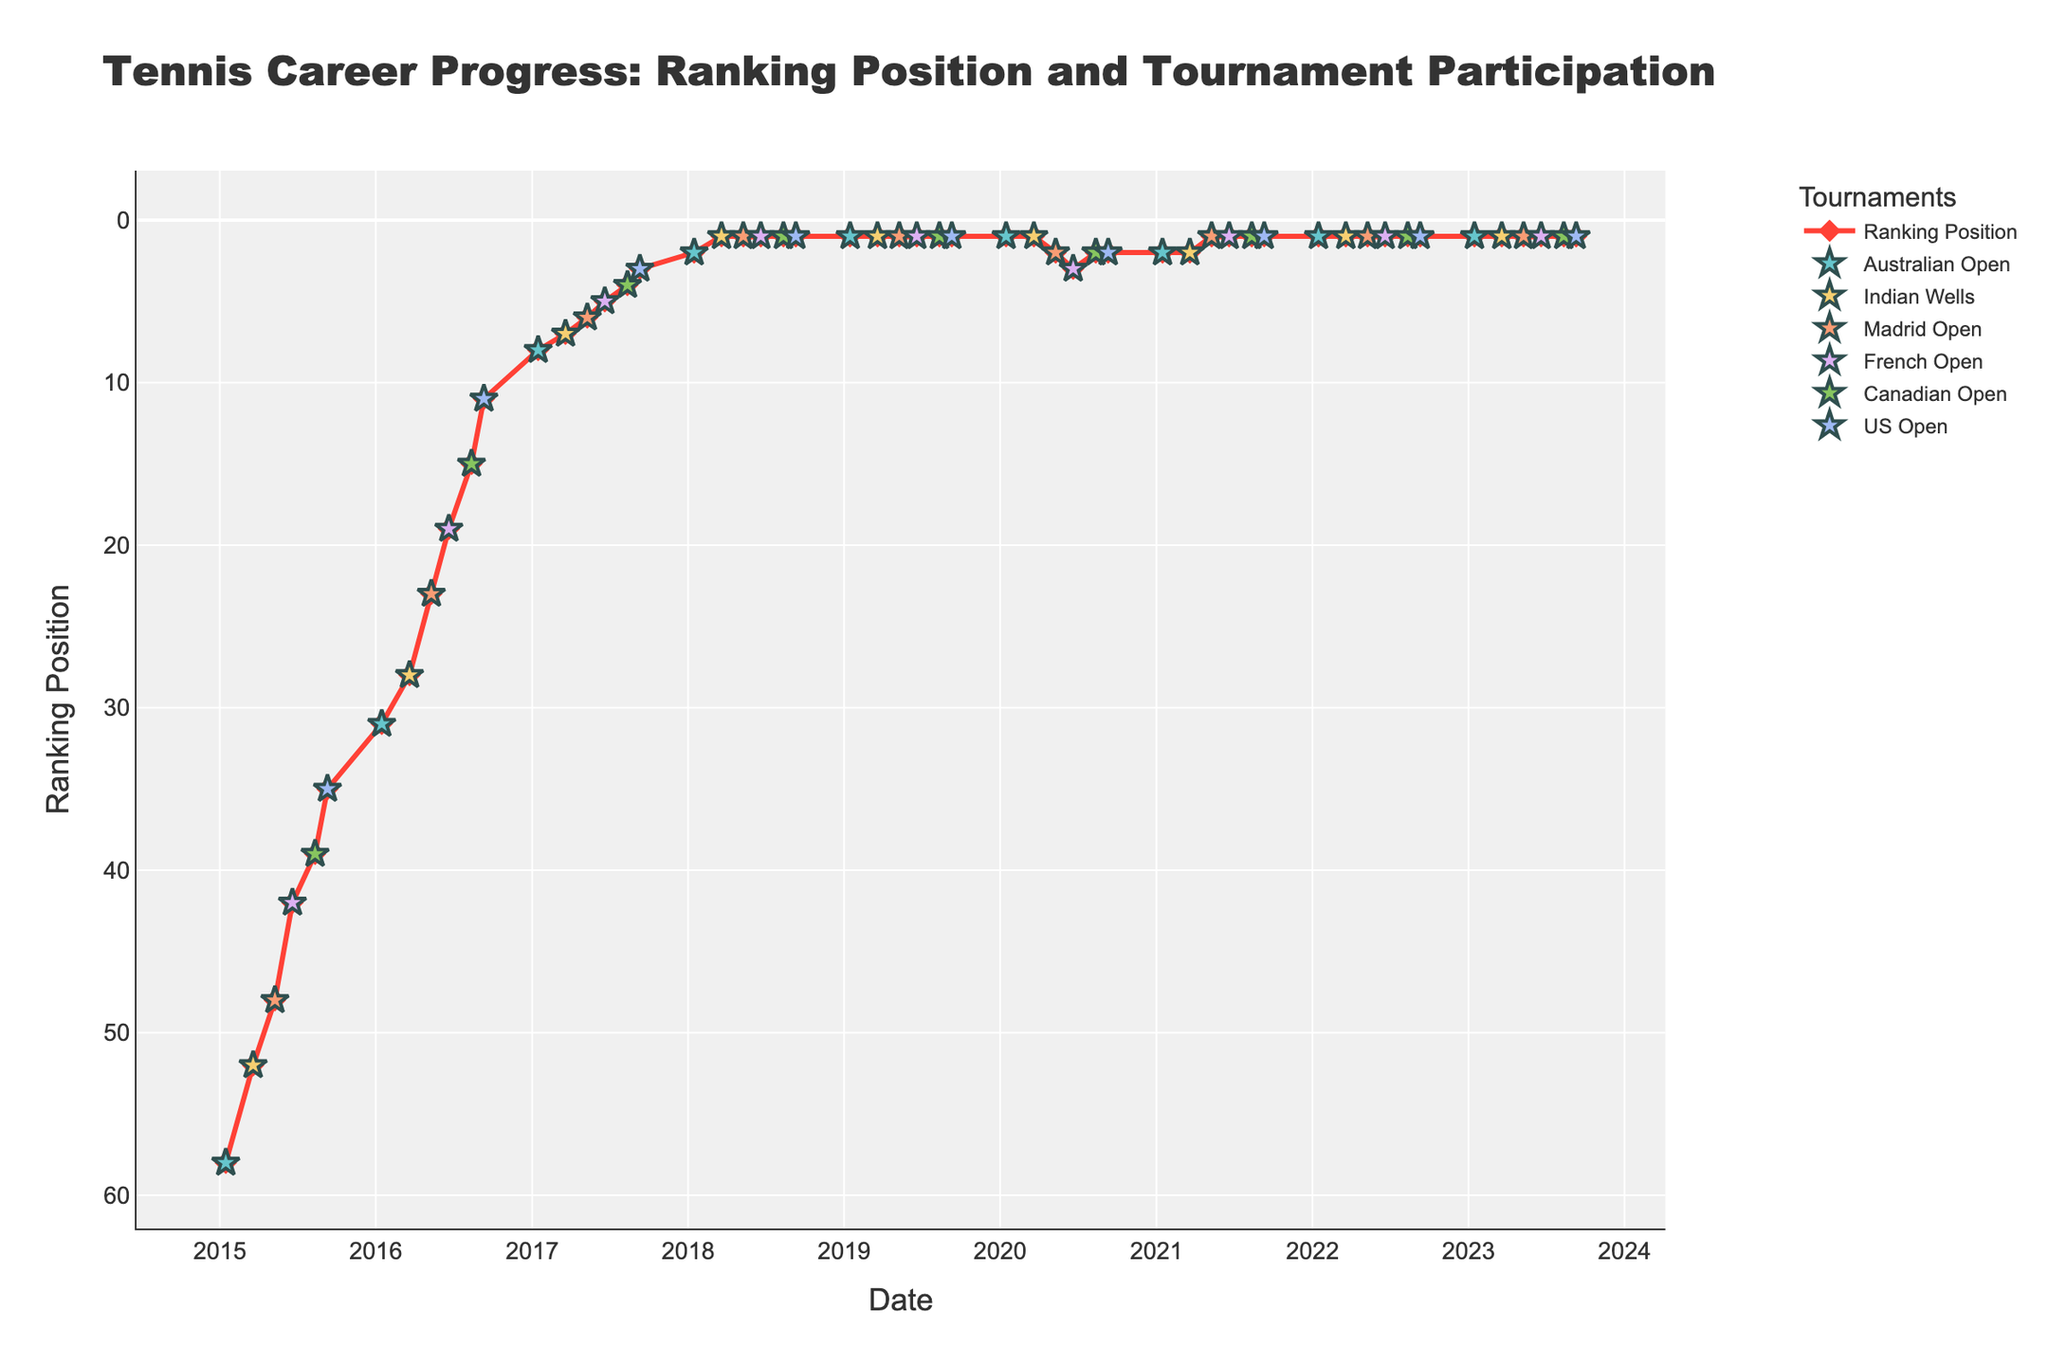What is the title of the plot? The title is displayed at the top of the plot. It's "Tennis Career Progress: Ranking Position and Tournament Participation".
Answer: Tennis Career Progress: Ranking Position and Tournament Participation What is the general trend of the ranking position from 2015 to 2018? To analyze the trend, look at the line that represents the ranking positions over time from 2015 to 2018. The ranking position consistently decreases, indicating improvement.
Answer: Improvement (ranking positions decrease) How many times did the ranking position reach 1? Look at the different points across the timeline that align with the ranking position of 1. There are 49 occurrences where the ranking position is 1.
Answer: 49 times Which tournament consistently appears in the data across the years, and how many times does it appear? Check the markers for different tournaments across the timeline. The 'Australian Open' can be found as a marker every year, from 2015 to 2023.
Answer: Australian Open, 9 times Between 2020 to 2023, what is the trend in ranking position, and during which tournament did it change? From 2020 to 2023, the ranking position mostly stays at 1 except for a brief period in 2020 where it changes. The ranking changes during the 'Madrid Open' and 'French Open' tournaments in 2020.
Answer: Brief fluctuation in 2020, Madrid Open and French Open How many tournaments were played in total from 2015 to 2023? Count the number of different markers representing tournaments on the plot. 7 unique tournaments are seen, and they are repetitive for each year.
Answer: 60 tournaments What was the ranking position during the 'US Open' in 2015, and how does it compare to the ranking position during the 'US Open' in 2016? Identify the markers for the 'US Open' in the years 2015 and 2016 and compare their values. Ranking position in 2015 is 35, whereas in 2016 it is 11. The ranking improved.
Answer: 35 in 2015, 11 in 2016 At what point does the ranking position first reach the top 5, and during which tournament? Locate the point in the timeline where the ranking position reaches 5 for the first time. This occurs during the 'French Open' in 2017.
Answer: French Open, 2017 Which tournament had the highest number of occurrences in the dataset, and how many times? Look for the event that appears most frequently by counting occurrences. The 'Australian Open' is the most frequent with 9 occurrences.
Answer: Australian Open, 9 times What is the lowest ranking position recorded, and in which year and tournament did it occur? The lowest ranking position is visually identifiable at the highest point in the y-axis (least value). It first occurs in the 'Indian Wells' of 2018.
Answer: 1, Indian Wells, 2018 